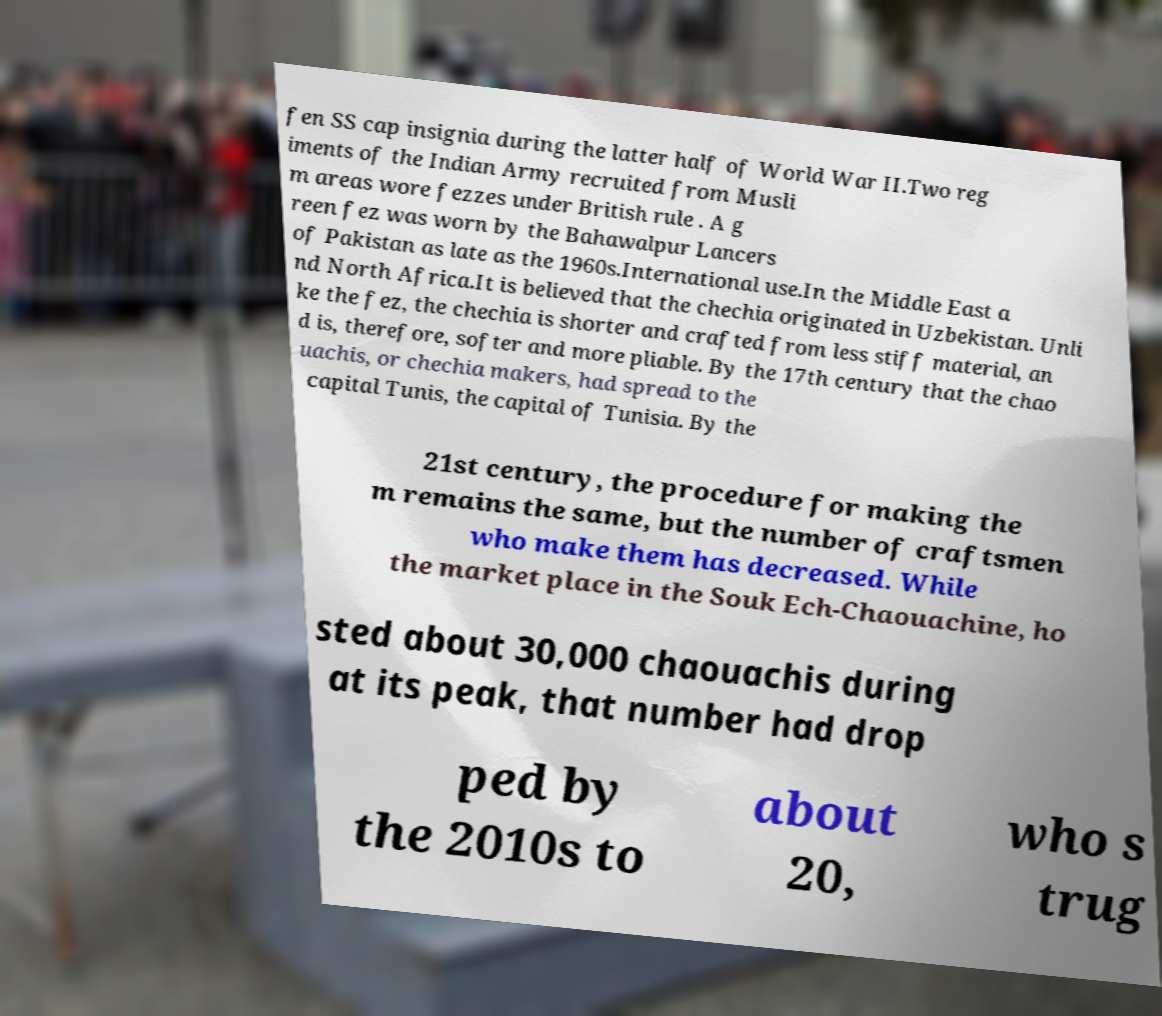I need the written content from this picture converted into text. Can you do that? fen SS cap insignia during the latter half of World War II.Two reg iments of the Indian Army recruited from Musli m areas wore fezzes under British rule . A g reen fez was worn by the Bahawalpur Lancers of Pakistan as late as the 1960s.International use.In the Middle East a nd North Africa.It is believed that the chechia originated in Uzbekistan. Unli ke the fez, the chechia is shorter and crafted from less stiff material, an d is, therefore, softer and more pliable. By the 17th century that the chao uachis, or chechia makers, had spread to the capital Tunis, the capital of Tunisia. By the 21st century, the procedure for making the m remains the same, but the number of craftsmen who make them has decreased. While the market place in the Souk Ech-Chaouachine, ho sted about 30,000 chaouachis during at its peak, that number had drop ped by the 2010s to about 20, who s trug 